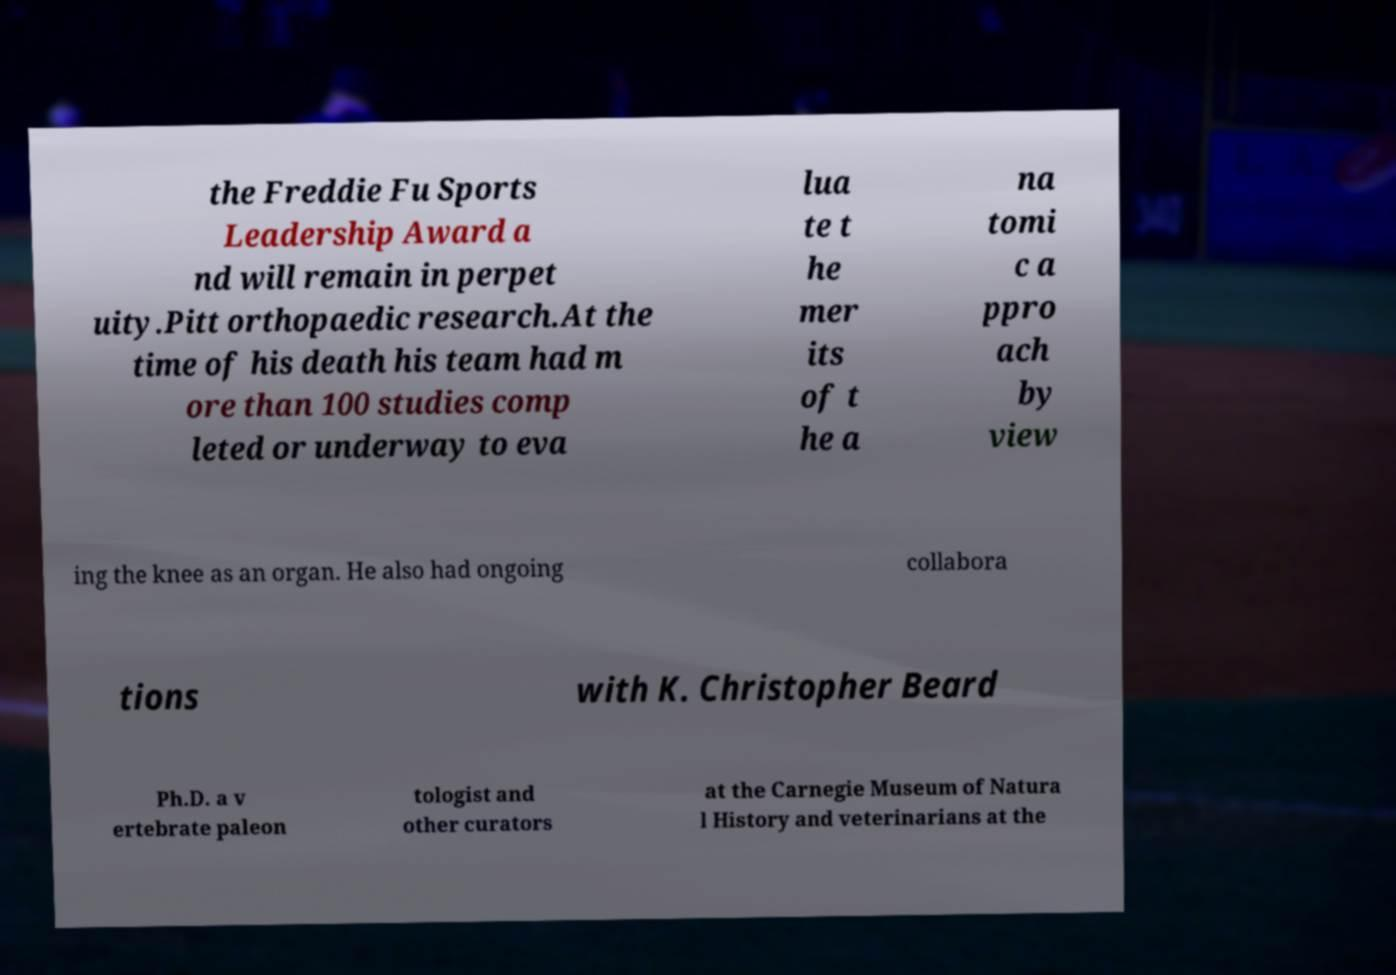Can you accurately transcribe the text from the provided image for me? the Freddie Fu Sports Leadership Award a nd will remain in perpet uity.Pitt orthopaedic research.At the time of his death his team had m ore than 100 studies comp leted or underway to eva lua te t he mer its of t he a na tomi c a ppro ach by view ing the knee as an organ. He also had ongoing collabora tions with K. Christopher Beard Ph.D. a v ertebrate paleon tologist and other curators at the Carnegie Museum of Natura l History and veterinarians at the 